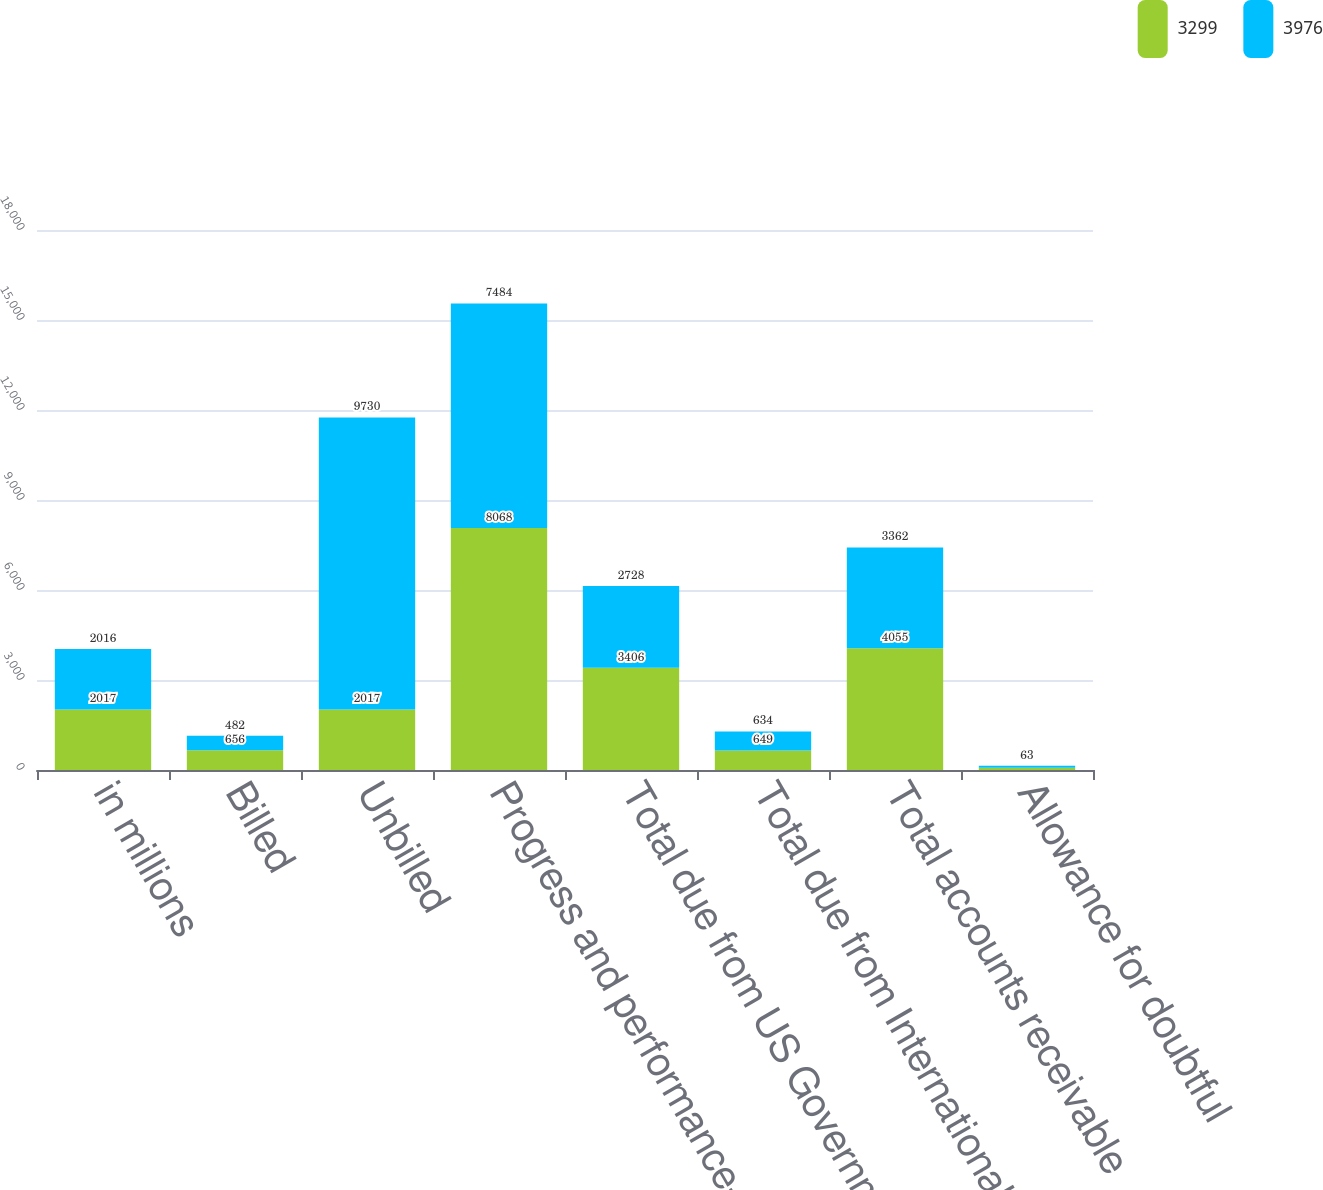<chart> <loc_0><loc_0><loc_500><loc_500><stacked_bar_chart><ecel><fcel>in millions<fcel>Billed<fcel>Unbilled<fcel>Progress and performance-based<fcel>Total due from US Government<fcel>Total due from International<fcel>Total accounts receivable<fcel>Allowance for doubtful<nl><fcel>3299<fcel>2017<fcel>656<fcel>2017<fcel>8068<fcel>3406<fcel>649<fcel>4055<fcel>79<nl><fcel>3976<fcel>2016<fcel>482<fcel>9730<fcel>7484<fcel>2728<fcel>634<fcel>3362<fcel>63<nl></chart> 